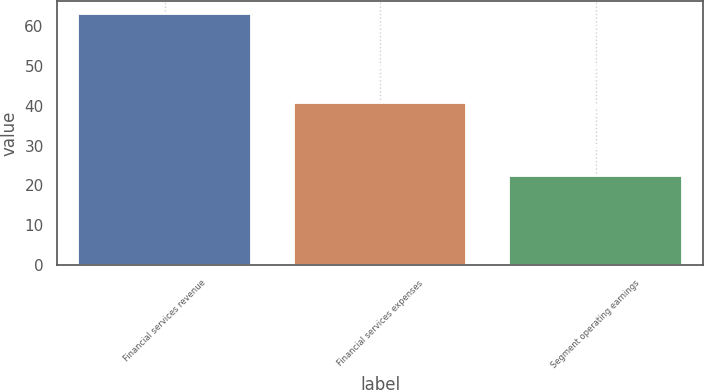<chart> <loc_0><loc_0><loc_500><loc_500><bar_chart><fcel>Financial services revenue<fcel>Financial services expenses<fcel>Segment operating earnings<nl><fcel>63<fcel>40.6<fcel>22.4<nl></chart> 